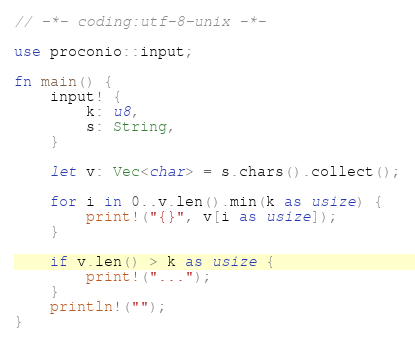<code> <loc_0><loc_0><loc_500><loc_500><_Rust_>// -*- coding:utf-8-unix -*-

use proconio::input;

fn main() {
    input! {
        k: u8,
        s: String,
    }

    let v: Vec<char> = s.chars().collect();

    for i in 0..v.len().min(k as usize) {
        print!("{}", v[i as usize]);
    }

    if v.len() > k as usize {
        print!("...");
    }
    println!("");
}
</code> 